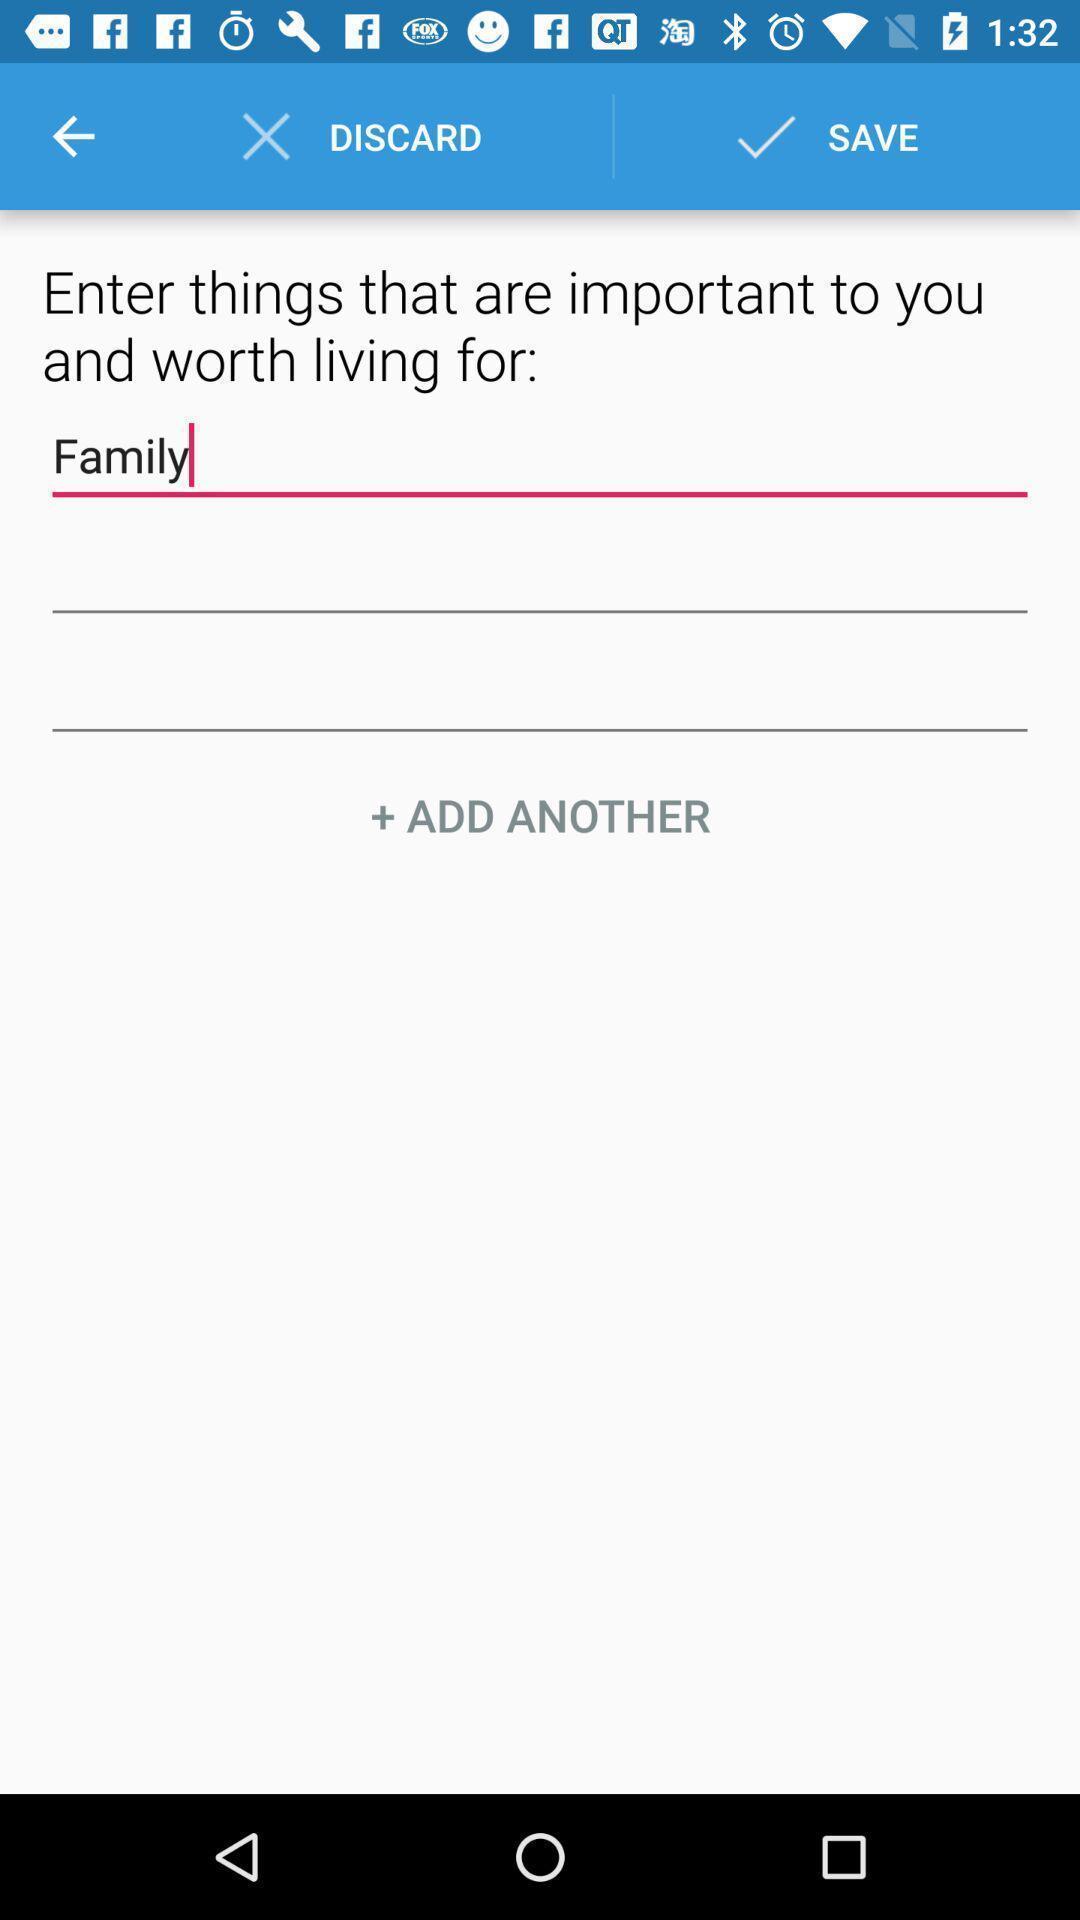Summarize the main components in this picture. Text is displaying to add into the mental health application. 